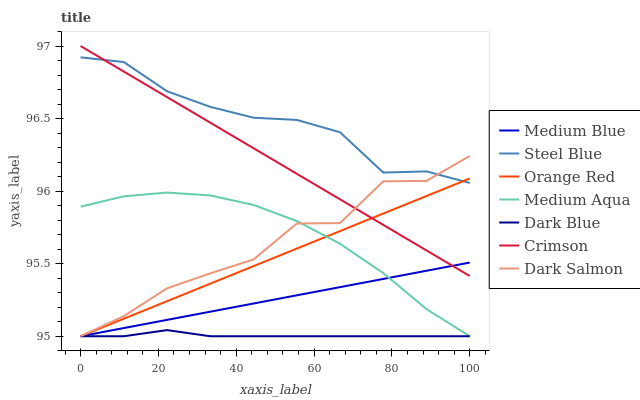Does Dark Blue have the minimum area under the curve?
Answer yes or no. Yes. Does Steel Blue have the maximum area under the curve?
Answer yes or no. Yes. Does Dark Salmon have the minimum area under the curve?
Answer yes or no. No. Does Dark Salmon have the maximum area under the curve?
Answer yes or no. No. Is Crimson the smoothest?
Answer yes or no. Yes. Is Dark Salmon the roughest?
Answer yes or no. Yes. Is Steel Blue the smoothest?
Answer yes or no. No. Is Steel Blue the roughest?
Answer yes or no. No. Does Medium Blue have the lowest value?
Answer yes or no. Yes. Does Steel Blue have the lowest value?
Answer yes or no. No. Does Crimson have the highest value?
Answer yes or no. Yes. Does Steel Blue have the highest value?
Answer yes or no. No. Is Medium Blue less than Steel Blue?
Answer yes or no. Yes. Is Steel Blue greater than Medium Aqua?
Answer yes or no. Yes. Does Orange Red intersect Dark Salmon?
Answer yes or no. Yes. Is Orange Red less than Dark Salmon?
Answer yes or no. No. Is Orange Red greater than Dark Salmon?
Answer yes or no. No. Does Medium Blue intersect Steel Blue?
Answer yes or no. No. 